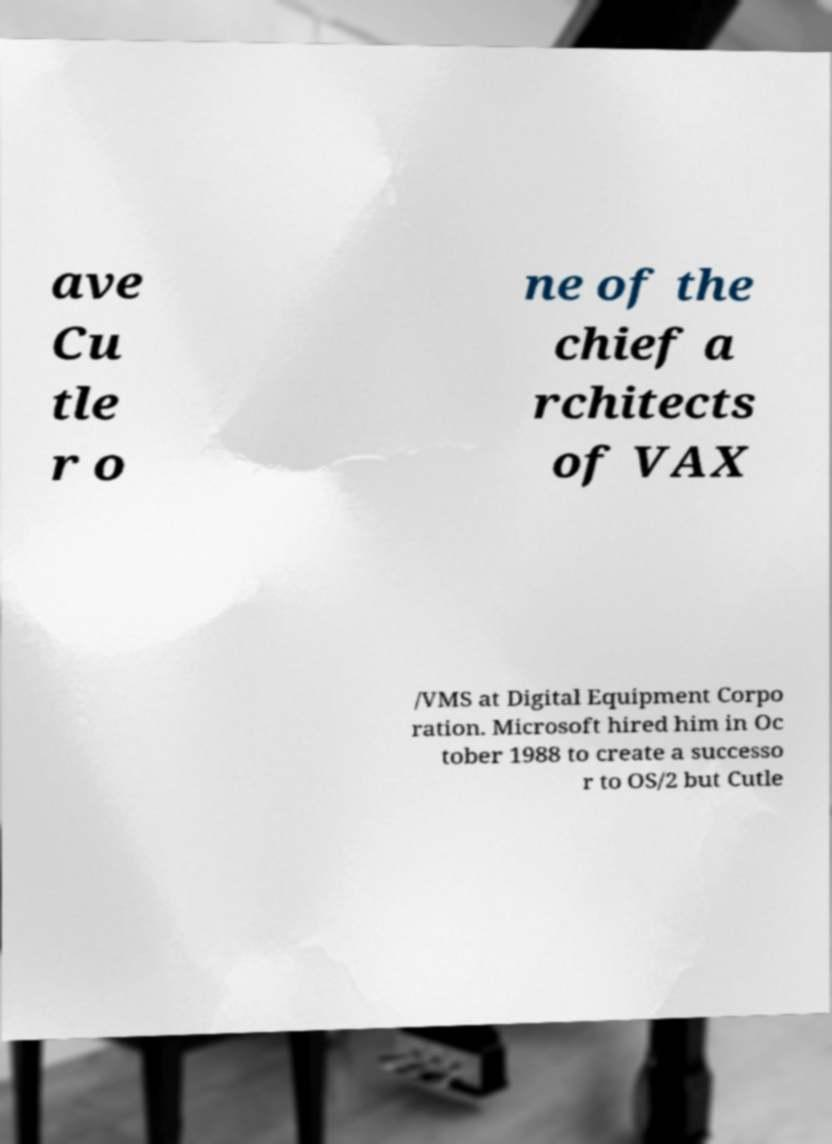Could you assist in decoding the text presented in this image and type it out clearly? ave Cu tle r o ne of the chief a rchitects of VAX /VMS at Digital Equipment Corpo ration. Microsoft hired him in Oc tober 1988 to create a successo r to OS/2 but Cutle 